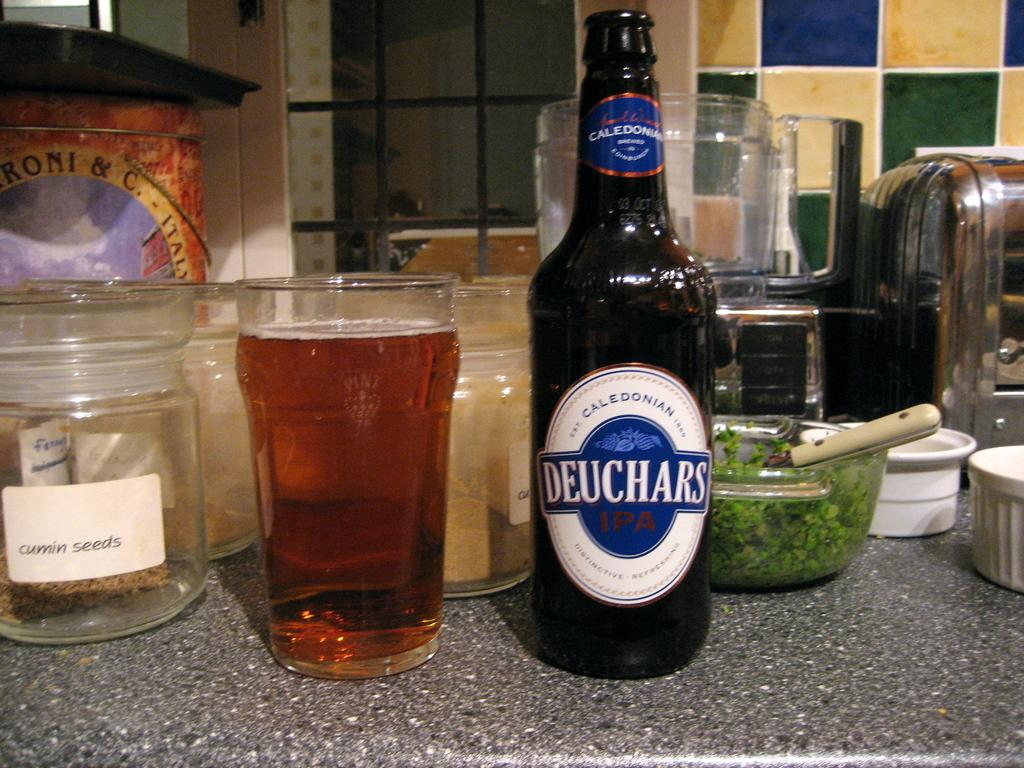<image>
Offer a succinct explanation of the picture presented. A bottle of Deuchars IPA is adjacent to a glass of beer on a kitchen counter. 